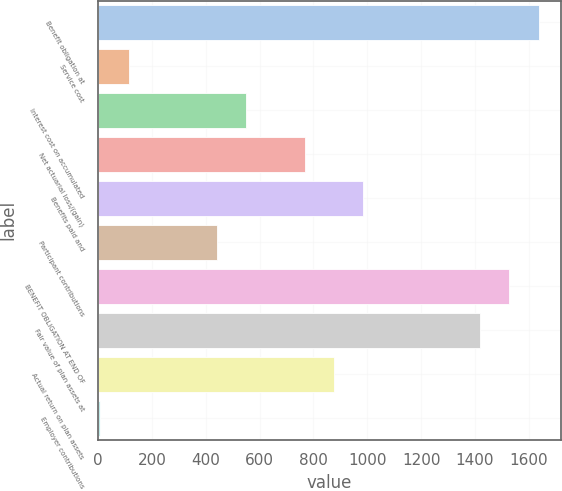Convert chart to OTSL. <chart><loc_0><loc_0><loc_500><loc_500><bar_chart><fcel>Benefit obligation at<fcel>Service cost<fcel>Interest cost on accumulated<fcel>Net actuarial loss/(gain)<fcel>Benefits paid and<fcel>Participant contributions<fcel>BENEFIT OBLIGATION AT END OF<fcel>Fair value of plan assets at<fcel>Actual return on plan assets<fcel>Employer contributions<nl><fcel>1636<fcel>115.6<fcel>550<fcel>767.2<fcel>984.4<fcel>441.4<fcel>1527.4<fcel>1418.8<fcel>875.8<fcel>7<nl></chart> 